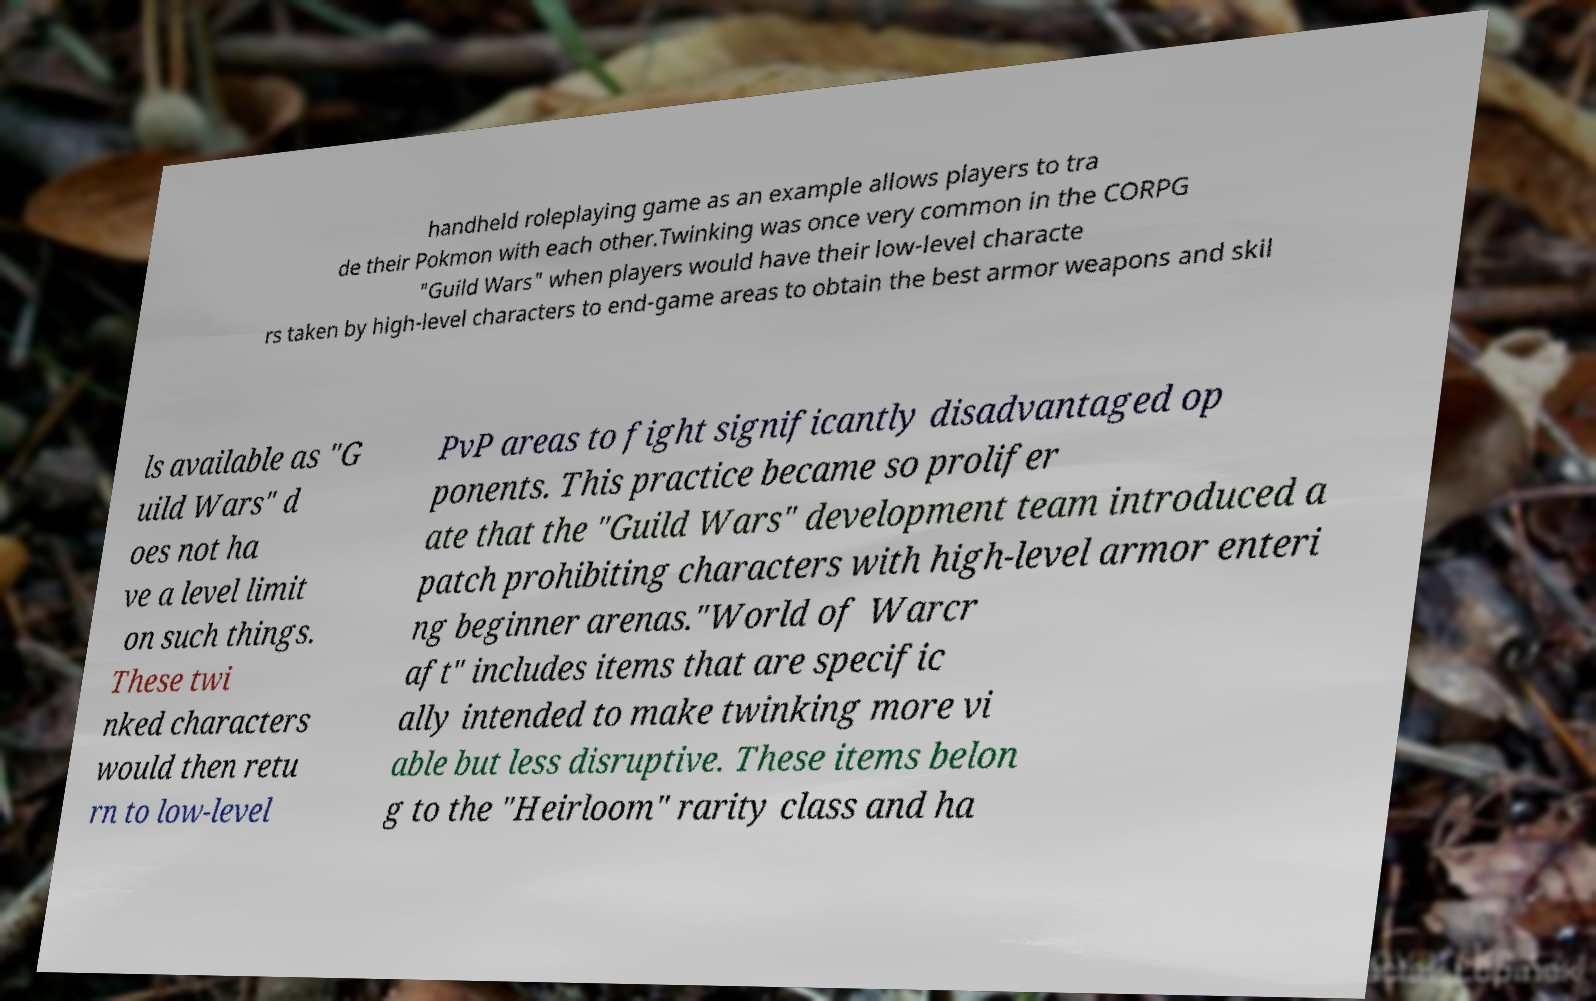Could you assist in decoding the text presented in this image and type it out clearly? handheld roleplaying game as an example allows players to tra de their Pokmon with each other.Twinking was once very common in the CORPG "Guild Wars" when players would have their low-level characte rs taken by high-level characters to end-game areas to obtain the best armor weapons and skil ls available as "G uild Wars" d oes not ha ve a level limit on such things. These twi nked characters would then retu rn to low-level PvP areas to fight significantly disadvantaged op ponents. This practice became so prolifer ate that the "Guild Wars" development team introduced a patch prohibiting characters with high-level armor enteri ng beginner arenas."World of Warcr aft" includes items that are specific ally intended to make twinking more vi able but less disruptive. These items belon g to the "Heirloom" rarity class and ha 